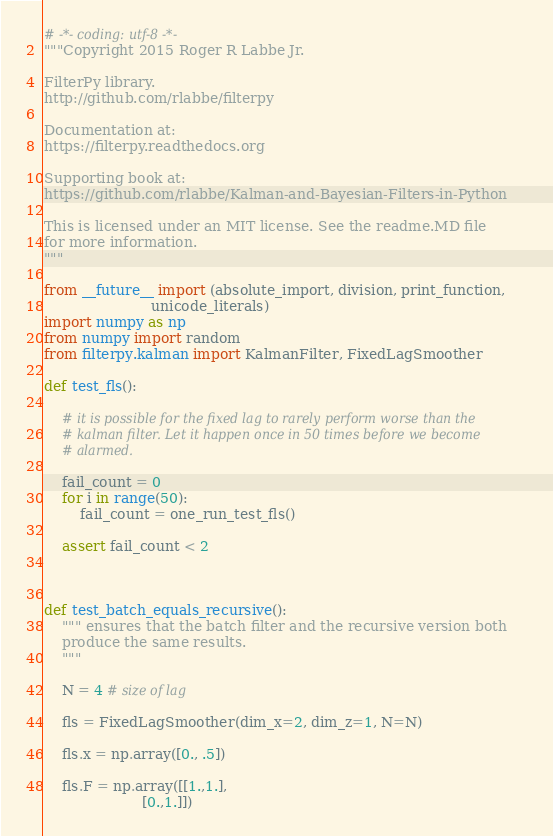Convert code to text. <code><loc_0><loc_0><loc_500><loc_500><_Python_># -*- coding: utf-8 -*-
"""Copyright 2015 Roger R Labbe Jr.

FilterPy library.
http://github.com/rlabbe/filterpy

Documentation at:
https://filterpy.readthedocs.org

Supporting book at:
https://github.com/rlabbe/Kalman-and-Bayesian-Filters-in-Python

This is licensed under an MIT license. See the readme.MD file
for more information.
"""

from __future__ import (absolute_import, division, print_function,
                        unicode_literals)
import numpy as np
from numpy import random
from filterpy.kalman import KalmanFilter, FixedLagSmoother

def test_fls():

    # it is possible for the fixed lag to rarely perform worse than the
    # kalman filter. Let it happen once in 50 times before we become
    # alarmed.

    fail_count = 0
    for i in range(50):
        fail_count = one_run_test_fls()

    assert fail_count < 2



def test_batch_equals_recursive():
    """ ensures that the batch filter and the recursive version both
    produce the same results.
    """

    N = 4 # size of lag

    fls = FixedLagSmoother(dim_x=2, dim_z=1, N=N)

    fls.x = np.array([0., .5])

    fls.F = np.array([[1.,1.],
                      [0.,1.]])
</code> 